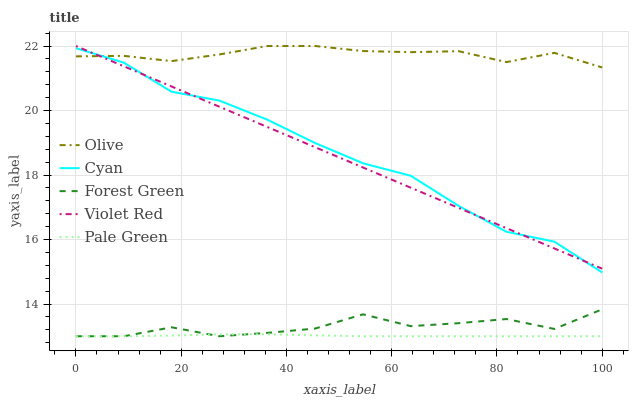Does Cyan have the minimum area under the curve?
Answer yes or no. No. Does Cyan have the maximum area under the curve?
Answer yes or no. No. Is Cyan the smoothest?
Answer yes or no. No. Is Cyan the roughest?
Answer yes or no. No. Does Cyan have the lowest value?
Answer yes or no. No. Does Cyan have the highest value?
Answer yes or no. No. Is Pale Green less than Violet Red?
Answer yes or no. Yes. Is Violet Red greater than Pale Green?
Answer yes or no. Yes. Does Pale Green intersect Violet Red?
Answer yes or no. No. 